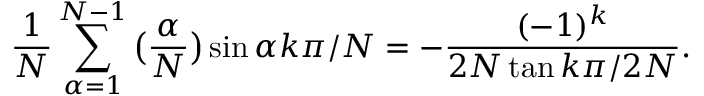Convert formula to latex. <formula><loc_0><loc_0><loc_500><loc_500>\frac { 1 } { N } \sum _ { \alpha = 1 } ^ { N - 1 } \left ( \frac { \alpha } { N } \right ) \sin \alpha k \pi / N = - \frac { ( - 1 ) ^ { k } } { 2 N \tan k \pi / 2 N } .</formula> 